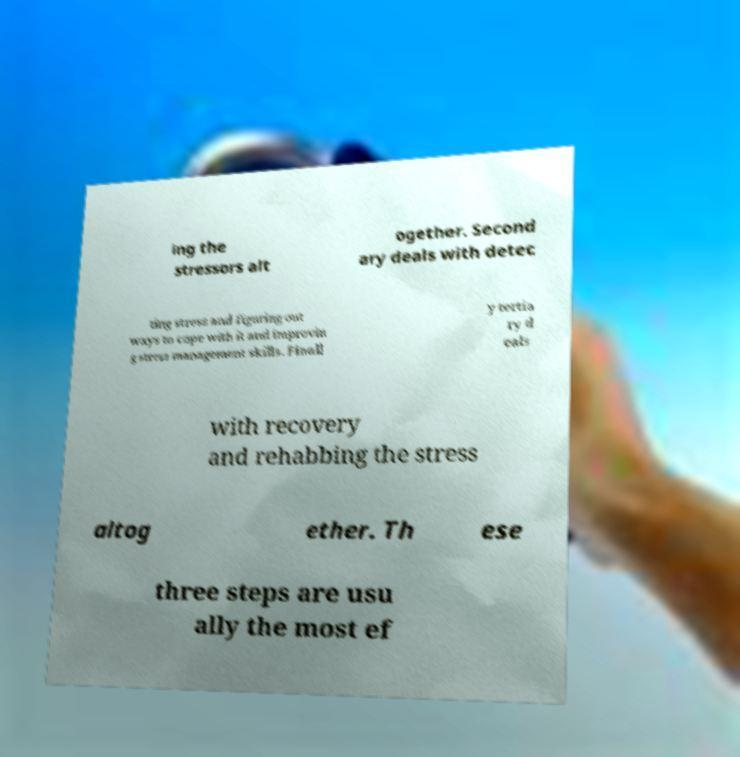Could you extract and type out the text from this image? ing the stressors alt ogether. Second ary deals with detec ting stress and figuring out ways to cope with it and improvin g stress management skills. Finall y tertia ry d eals with recovery and rehabbing the stress altog ether. Th ese three steps are usu ally the most ef 